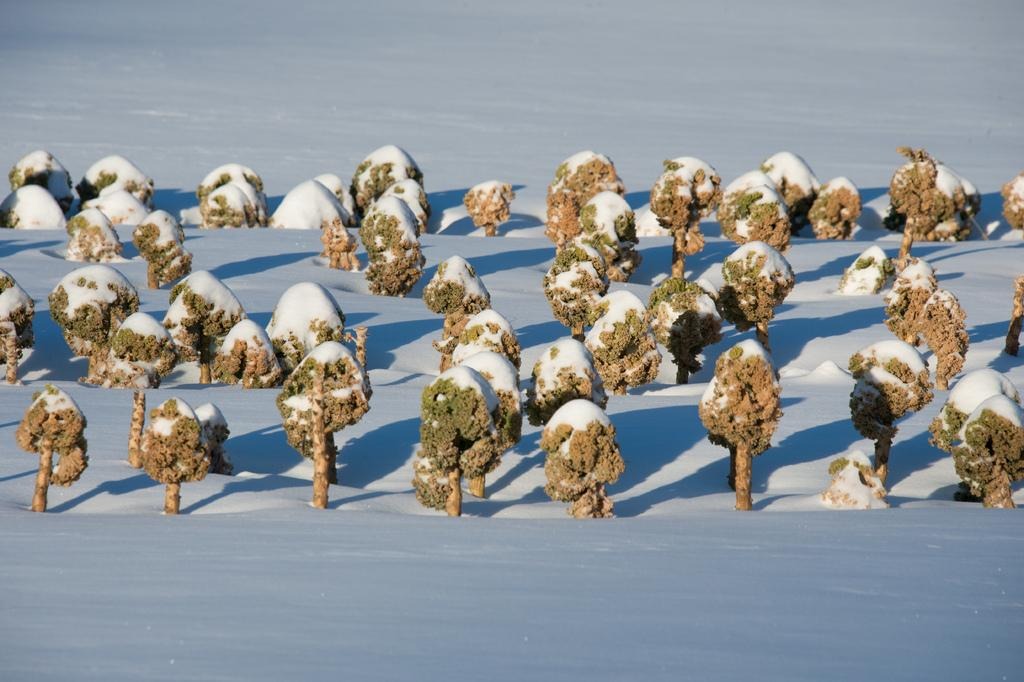What type of surface is shown in the image? The image shows a snow surface. Are there any objects or structures on the snow surface? Yes, there are trees on the snow surface. What is the primary feature of the snow surface? The primary feature of the snow surface is the presence of snow. What type of table can be seen in the image? There is no table present in the image; it shows a snow surface with trees and snow. How many circles are visible in the image? There are no circles visible in the image; it shows a snow surface with trees and snow. 